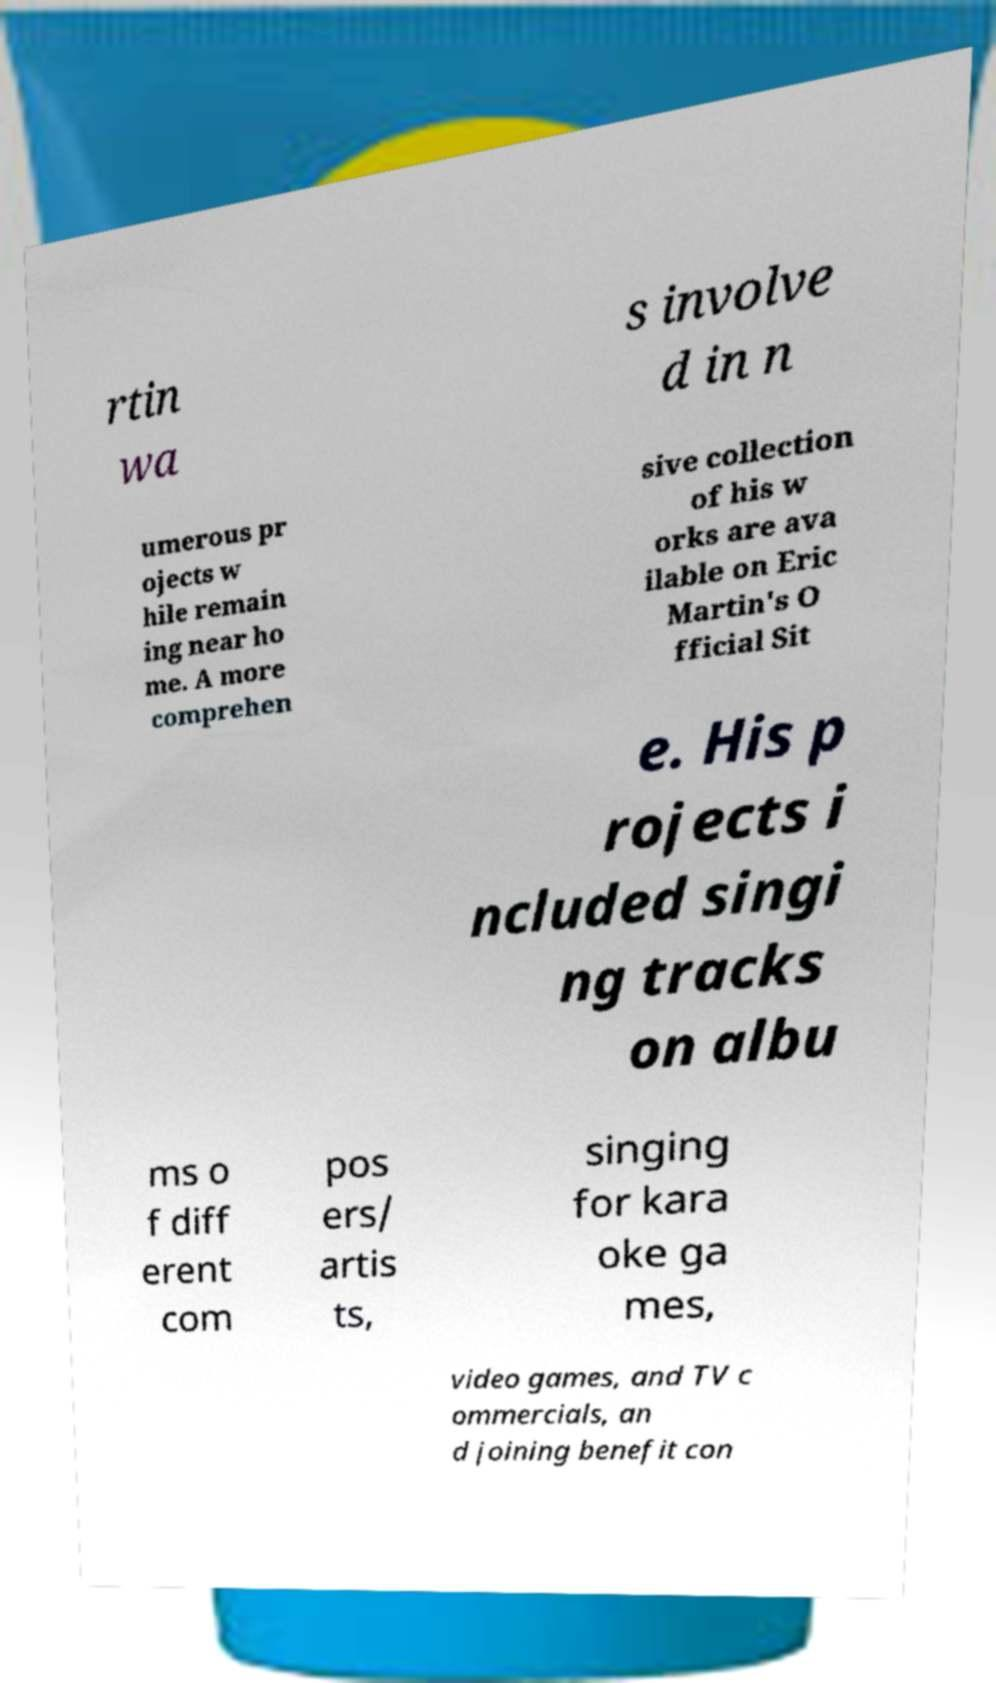There's text embedded in this image that I need extracted. Can you transcribe it verbatim? rtin wa s involve d in n umerous pr ojects w hile remain ing near ho me. A more comprehen sive collection of his w orks are ava ilable on Eric Martin's O fficial Sit e. His p rojects i ncluded singi ng tracks on albu ms o f diff erent com pos ers/ artis ts, singing for kara oke ga mes, video games, and TV c ommercials, an d joining benefit con 